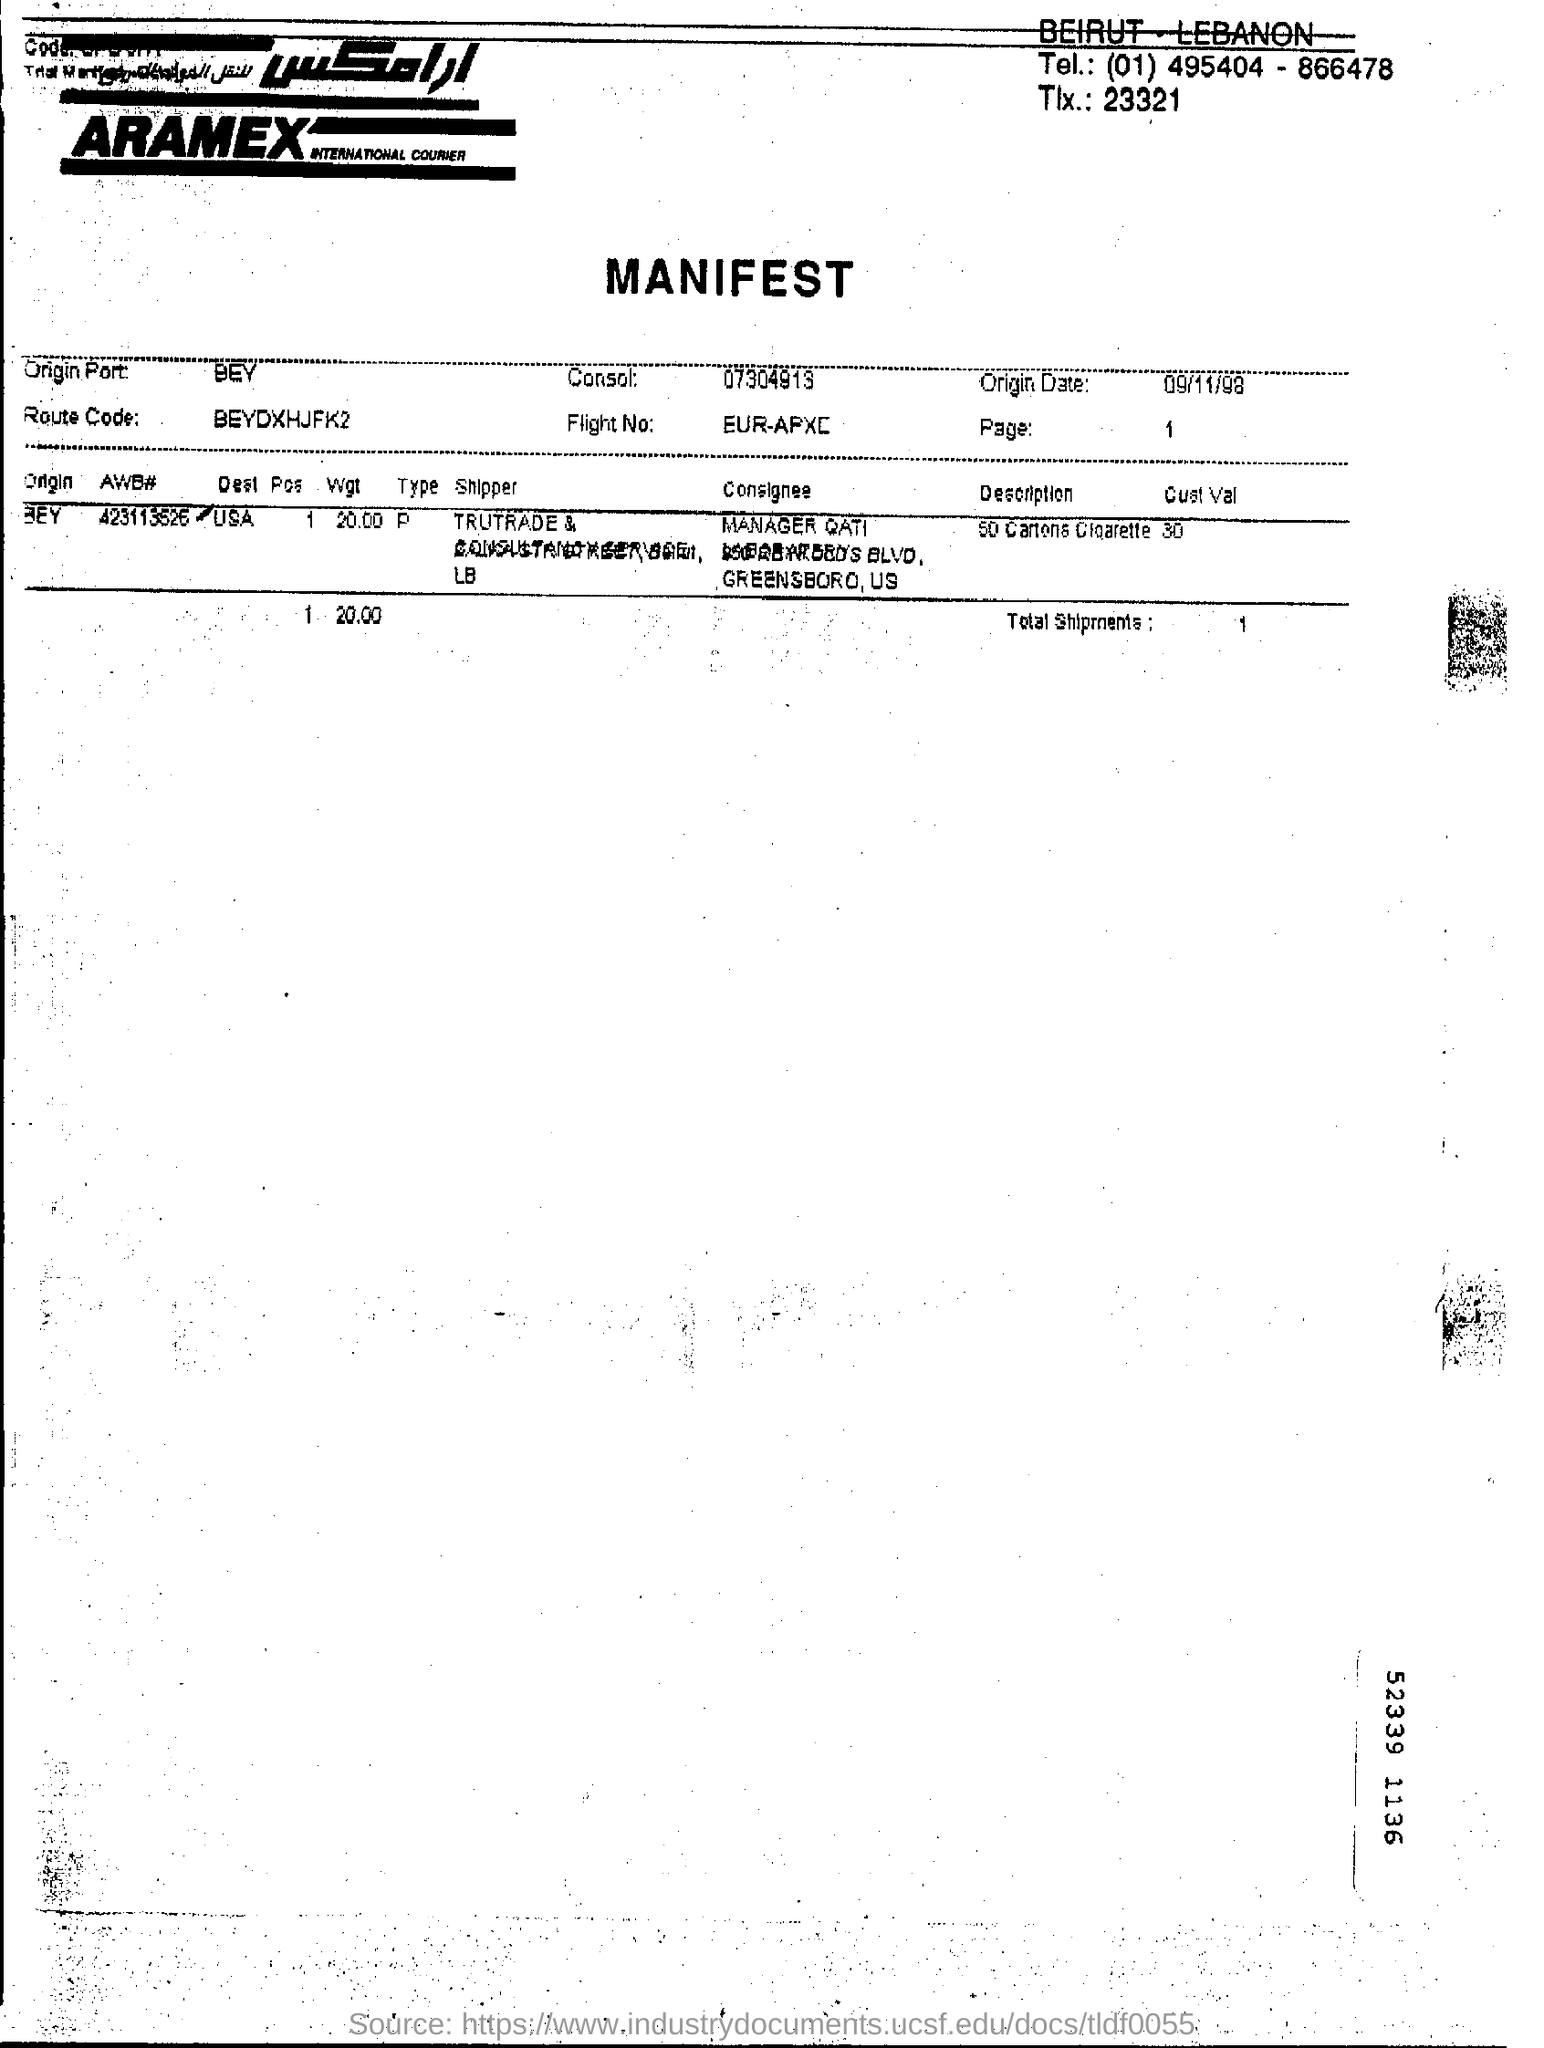List a handful of essential elements in this visual. What is the route code?" is a question asking for information about a specific code. The code in question is "BEYDXHJFK2," which appears to be a route code of some kind. A route code is a set of instructions used to guide a vehicle from one location to another. Therefore, the question is asking for information about a code that is used to guide a vehicle from one location to another. The origin date is September 11, 1998. 